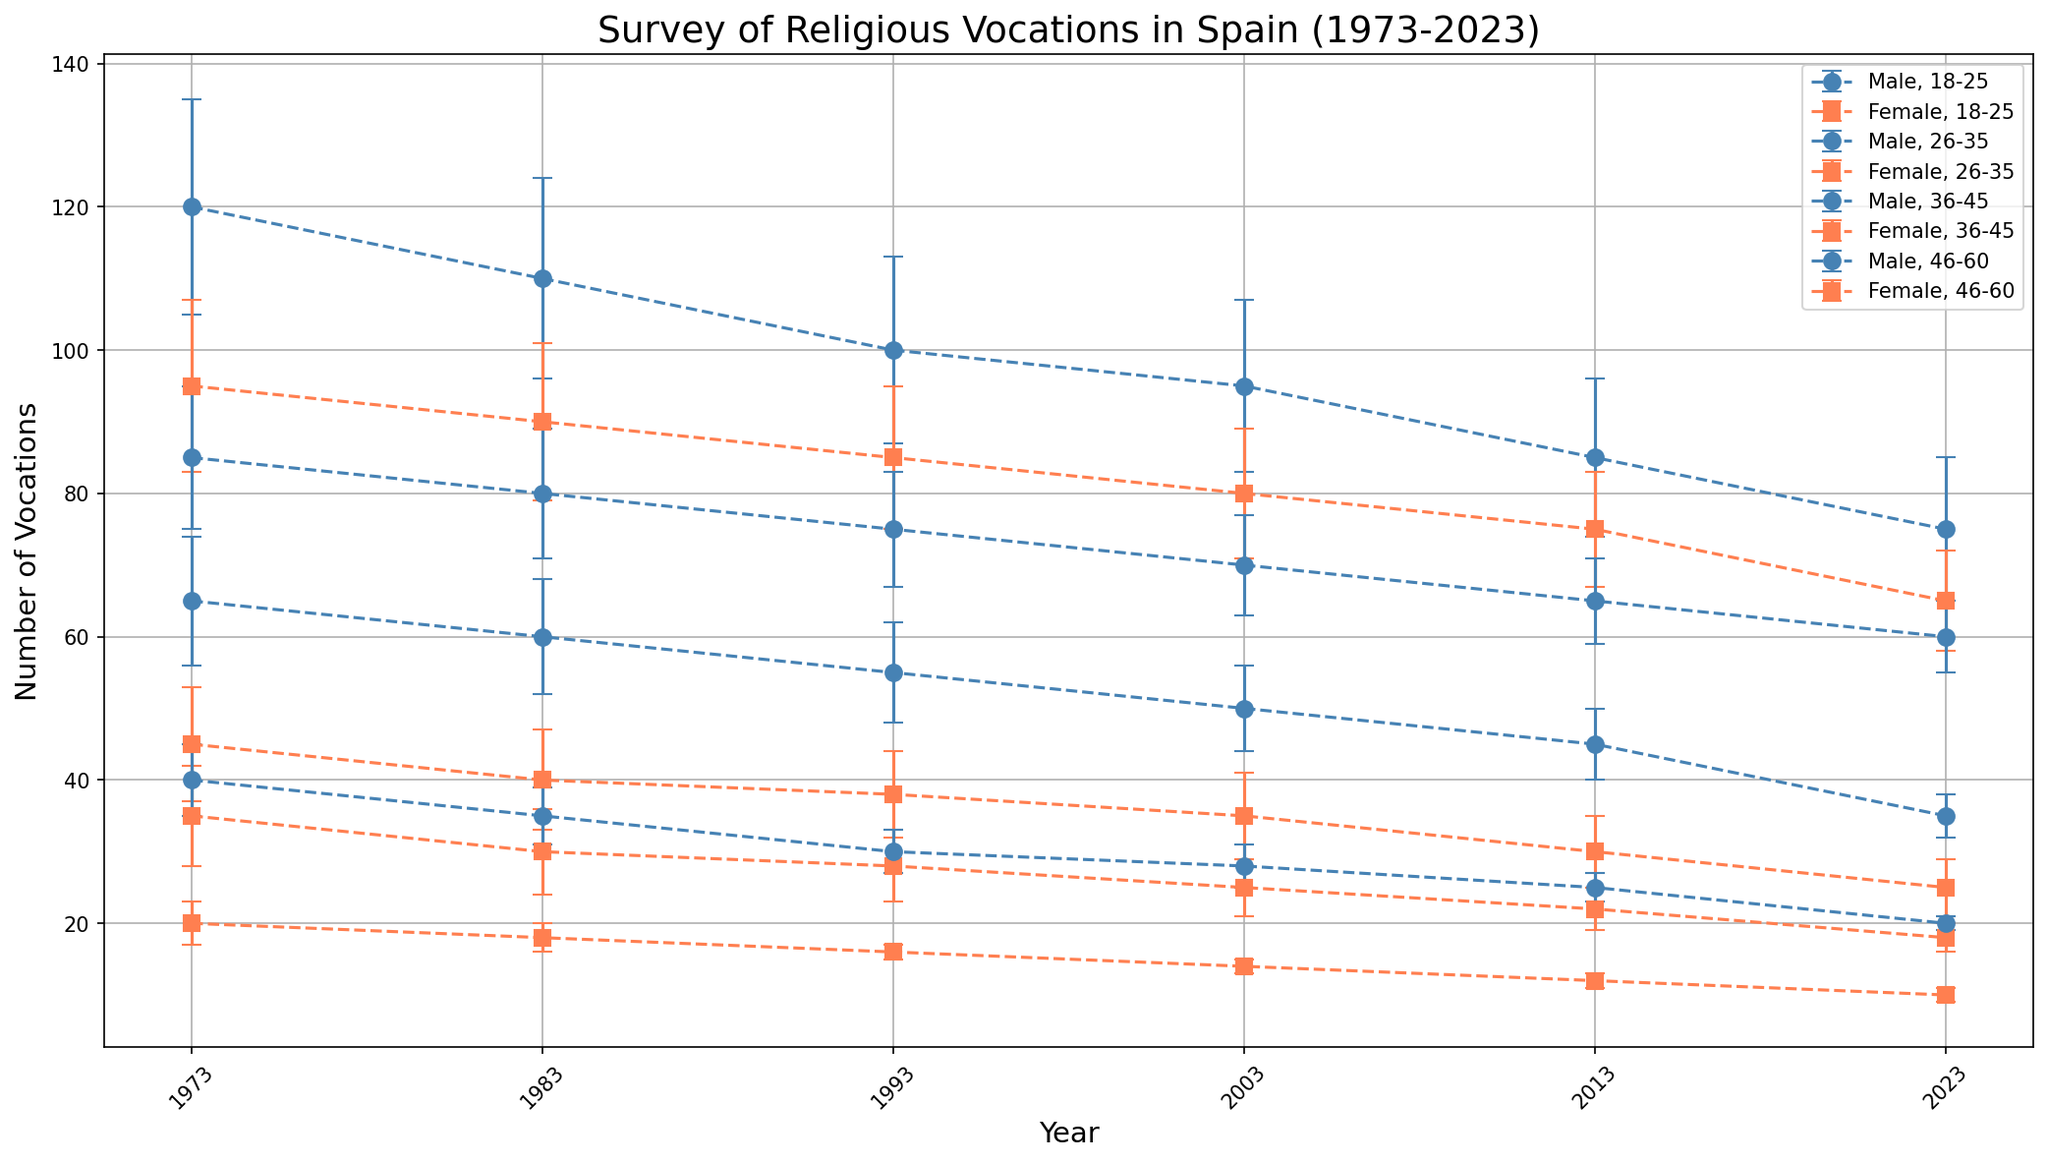Which age group and gender had the highest number of religious vocations in 1973? To determine this, we examine the figure for the highest points in the year 1973. The 18-25 age group, male gender data point shows the highest number of vocations at 120.
Answer: 18-25, Male How has the number of vocations for females aged 26-35 changed from 1983 to 2023? We find the points for the female, 26-35 age group in 1983 and 2023 in the figure. In 1983, it is 40, and in 2023, it is 25. Therefore, it decreased by 15.
Answer: Decreased by 15 What is the average number of vocations for males aged 46-60 over the entire 50-year period presented? Adding up the number of vocations for males aged 46-60 for the years provided (40, 35, 30, 28, 25, 20) and then dividing by the number of years (6), we get (40+35+30+28+25+20)/6 = 178/6 = 29.67.
Answer: 29.67 Which gender has shown a greater decline in vocations for the 18-25 age group from 1973 to 2023? Comparing the figure points for the 18-25 age group in 1973 and 2023, for males, the numbers are 120 in 1973 and 75 in 2023 (decline of 45). For females, the numbers are 95 in 1973 and 65 in 2023 (decline of 30). Thus, males have a greater decline.
Answer: Males What is the trend observed for religious vocations among males aged 36-45 from 1973 to 2023? Observing the 36-45 age group for males on the graph, we see a consistent decline from 65 in 1973 to 35 in 2023, showing a general downward trend.
Answer: Downward trend What is the difference in the number of vocations between males and females aged 26-35 in 2013? From the figure, for the 26-35 age group in 2013, males have 65 vocations and females 30. The difference is 65 - 30 = 35.
Answer: 35 Which year shows a narrower error margin for the 18-25 age group for females? Checking the figure for the error bars of females aged 18-25, the smallest error bars occur in 2023 with a value of 7.
Answer: 2023 What is the difference in the number of vocations for the 36-45 age group males between the highest and lowest years? From the figure, the highest number of vocations for 36-45 males is 65 in 1973, and the lowest is 35 in 2023. The difference is 65 - 35 = 30.
Answer: 30 How do the total number of vocations for males and females aged 18-25 compare in 2023? Checking the values for the 18-25 age group in 2023, we observe males have 75 vocations and females have 65. So, there are more vocations for males than females by a difference of 10.
Answer: Males by 10 